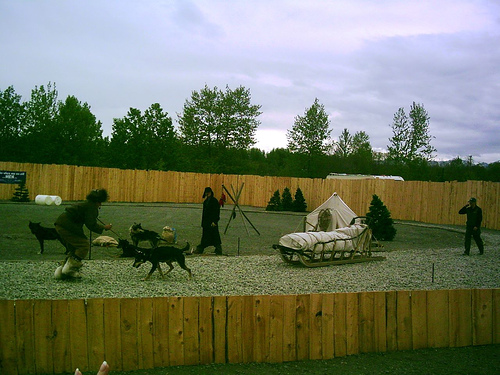What can you infer about the dogs' breeds and their suitability for this activity? The dogs appear to be of a breed typically used for endurance activities like sled pulling. They have a sturdy build, thick coats, and show enthusiasm for the activity, which are hallmarks of breeds like Siberian Huskies or Alaskan Malamutes. These breeds are well-suited for such demanding physical tasks due to their strength, stamina, and heritage of working in harsh, cold environments, even though this particular setting does not reflect their traditional working conditions. 